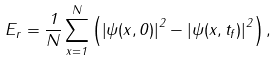Convert formula to latex. <formula><loc_0><loc_0><loc_500><loc_500>E _ { r } = \frac { 1 } { N } \sum _ { x = 1 } ^ { N } \left ( \left | \psi ( x , 0 ) \right | ^ { 2 } - \left | \psi ( x , t _ { f } ) \right | ^ { 2 } \right ) ,</formula> 